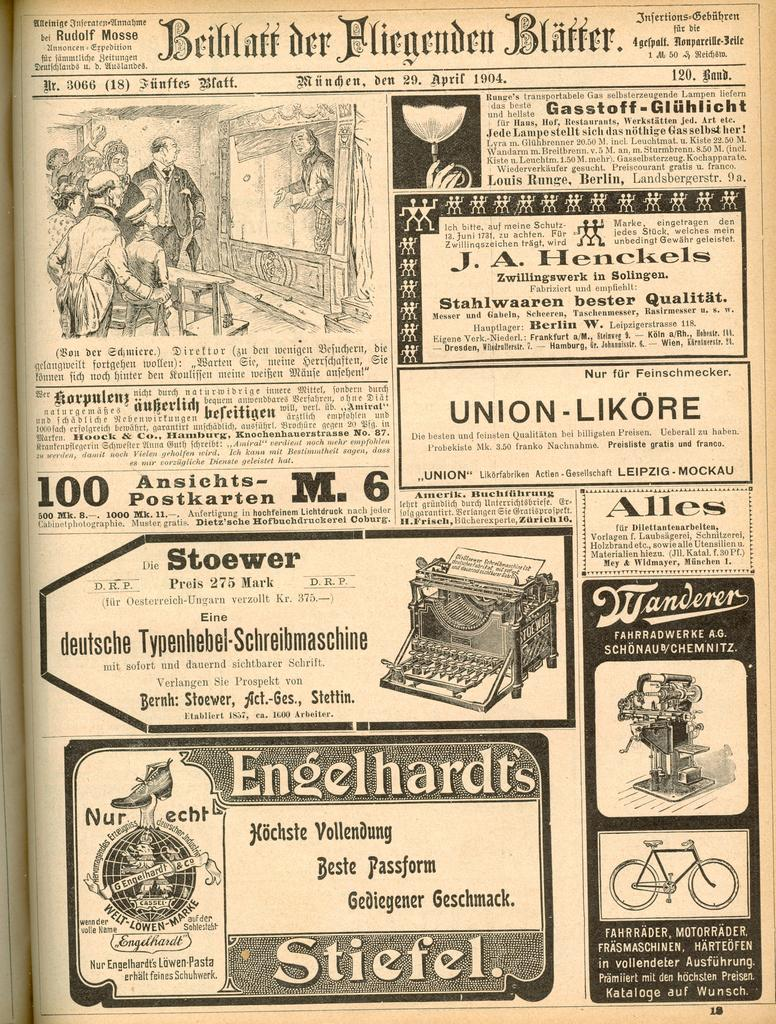<image>
Provide a brief description of the given image. the word union is on the dark piece of paper 